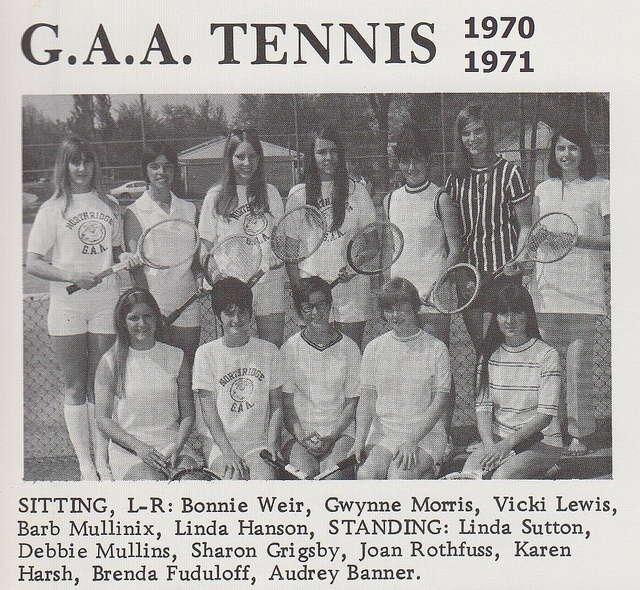Describe the objects in this image and their specific colors. I can see people in lightgray, darkgray, and gray tones, people in lightgray, darkgray, and gray tones, people in lightgray, darkgray, and gray tones, people in lightgray, darkgray, and gray tones, and people in lightgray, gray, darkgray, and black tones in this image. 